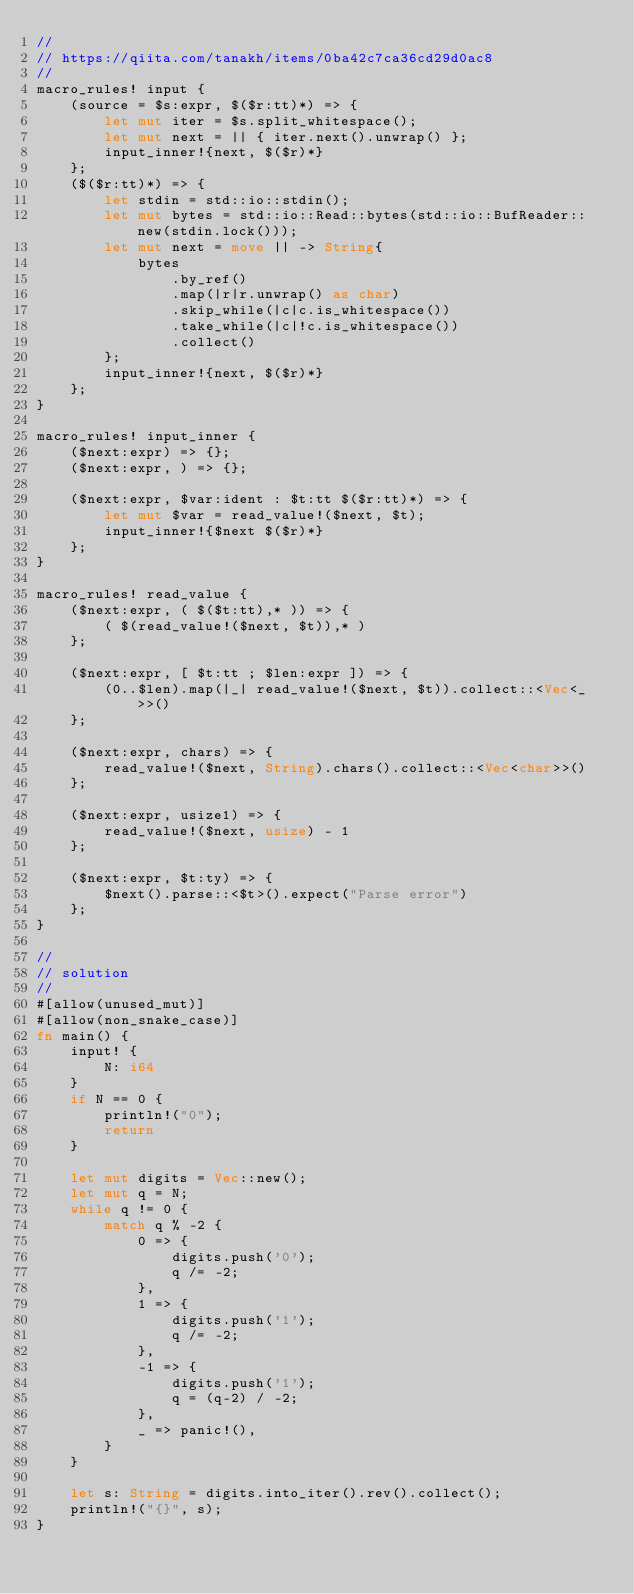<code> <loc_0><loc_0><loc_500><loc_500><_Rust_>//
// https://qiita.com/tanakh/items/0ba42c7ca36cd29d0ac8
//
macro_rules! input {
    (source = $s:expr, $($r:tt)*) => {
        let mut iter = $s.split_whitespace();
        let mut next = || { iter.next().unwrap() };
        input_inner!{next, $($r)*}
    };
    ($($r:tt)*) => {
        let stdin = std::io::stdin();
        let mut bytes = std::io::Read::bytes(std::io::BufReader::new(stdin.lock()));
        let mut next = move || -> String{
            bytes
                .by_ref()
                .map(|r|r.unwrap() as char)
                .skip_while(|c|c.is_whitespace())
                .take_while(|c|!c.is_whitespace())
                .collect()
        };
        input_inner!{next, $($r)*}
    };
}

macro_rules! input_inner {
    ($next:expr) => {};
    ($next:expr, ) => {};

    ($next:expr, $var:ident : $t:tt $($r:tt)*) => {
        let mut $var = read_value!($next, $t);
        input_inner!{$next $($r)*}
    };
}

macro_rules! read_value {
    ($next:expr, ( $($t:tt),* )) => {
        ( $(read_value!($next, $t)),* )
    };

    ($next:expr, [ $t:tt ; $len:expr ]) => {
        (0..$len).map(|_| read_value!($next, $t)).collect::<Vec<_>>()
    };

    ($next:expr, chars) => {
        read_value!($next, String).chars().collect::<Vec<char>>()
    };

    ($next:expr, usize1) => {
        read_value!($next, usize) - 1
    };

    ($next:expr, $t:ty) => {
        $next().parse::<$t>().expect("Parse error")
    };
}

//
// solution 
//
#[allow(unused_mut)]
#[allow(non_snake_case)]
fn main() {
    input! {
        N: i64
    }
    if N == 0 {
        println!("0");
        return
    }

    let mut digits = Vec::new();
    let mut q = N;
    while q != 0 {
        match q % -2 {
            0 => {
                digits.push('0');
                q /= -2;
            },
            1 => {
                digits.push('1');
                q /= -2;
            },
            -1 => {
                digits.push('1');
                q = (q-2) / -2;
            },
            _ => panic!(),
        }
    }

    let s: String = digits.into_iter().rev().collect();
    println!("{}", s);
}
</code> 